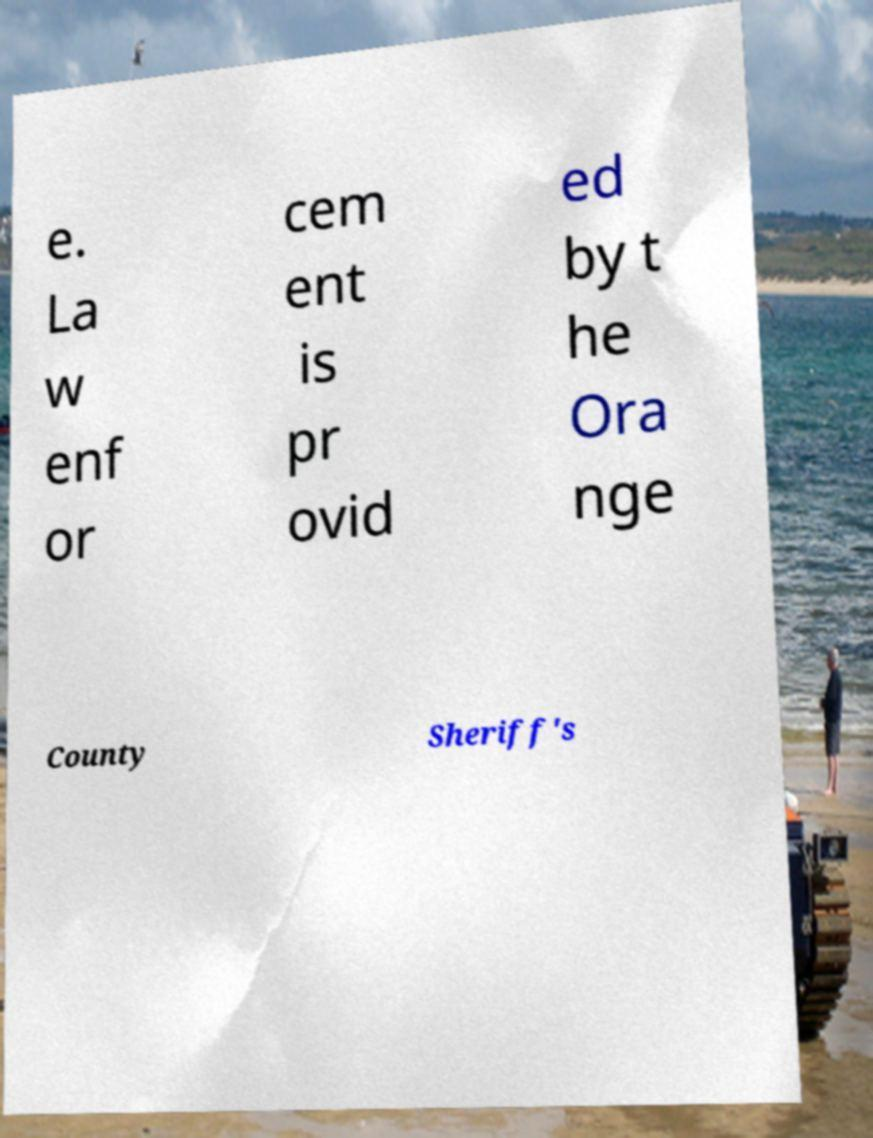There's text embedded in this image that I need extracted. Can you transcribe it verbatim? e. La w enf or cem ent is pr ovid ed by t he Ora nge County Sheriff's 